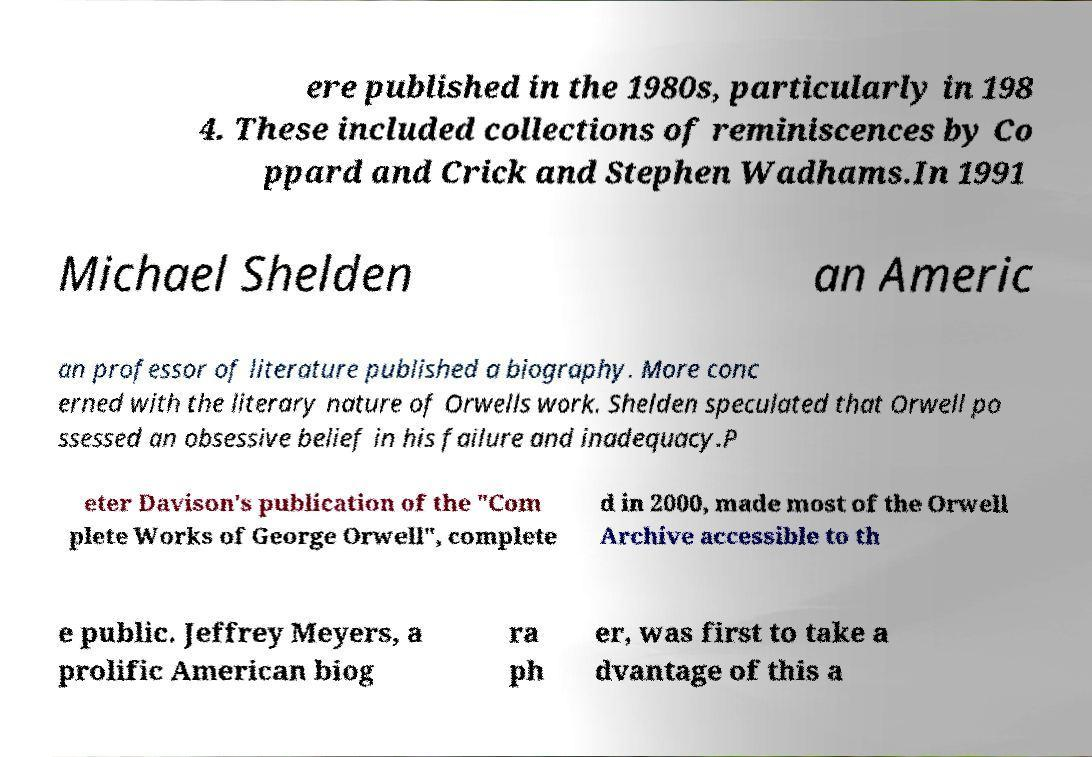Can you read and provide the text displayed in the image?This photo seems to have some interesting text. Can you extract and type it out for me? ere published in the 1980s, particularly in 198 4. These included collections of reminiscences by Co ppard and Crick and Stephen Wadhams.In 1991 Michael Shelden an Americ an professor of literature published a biography. More conc erned with the literary nature of Orwells work. Shelden speculated that Orwell po ssessed an obsessive belief in his failure and inadequacy.P eter Davison's publication of the "Com plete Works of George Orwell", complete d in 2000, made most of the Orwell Archive accessible to th e public. Jeffrey Meyers, a prolific American biog ra ph er, was first to take a dvantage of this a 